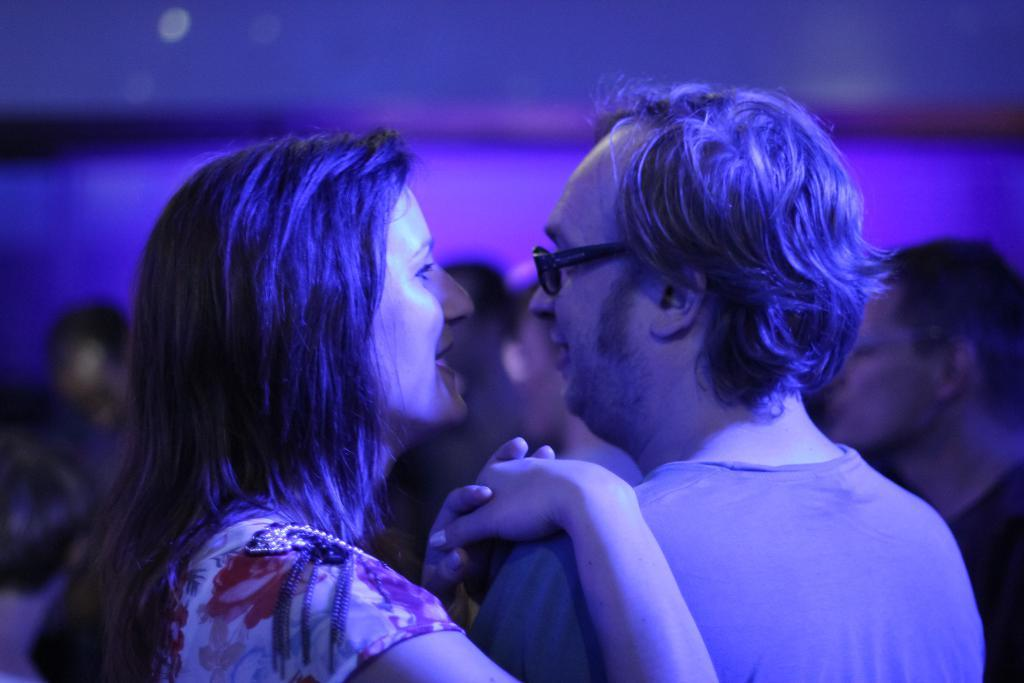How many people are in the image? There are people in the image, but the exact number is not specified. Where are the people located in the image? The people are standing in the middle of the image. What type of vase is being used to apply force in the image? There is no vase or force present in the image; it only features people standing in the middle. 